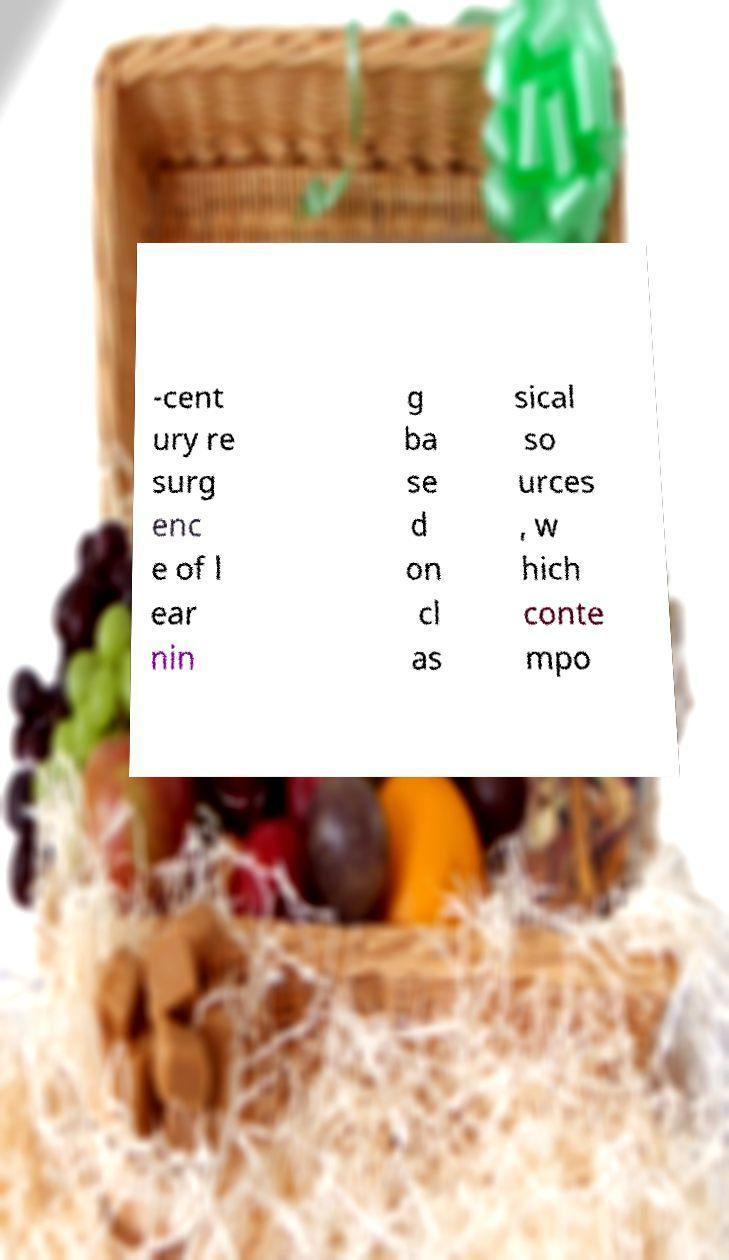Could you extract and type out the text from this image? -cent ury re surg enc e of l ear nin g ba se d on cl as sical so urces , w hich conte mpo 